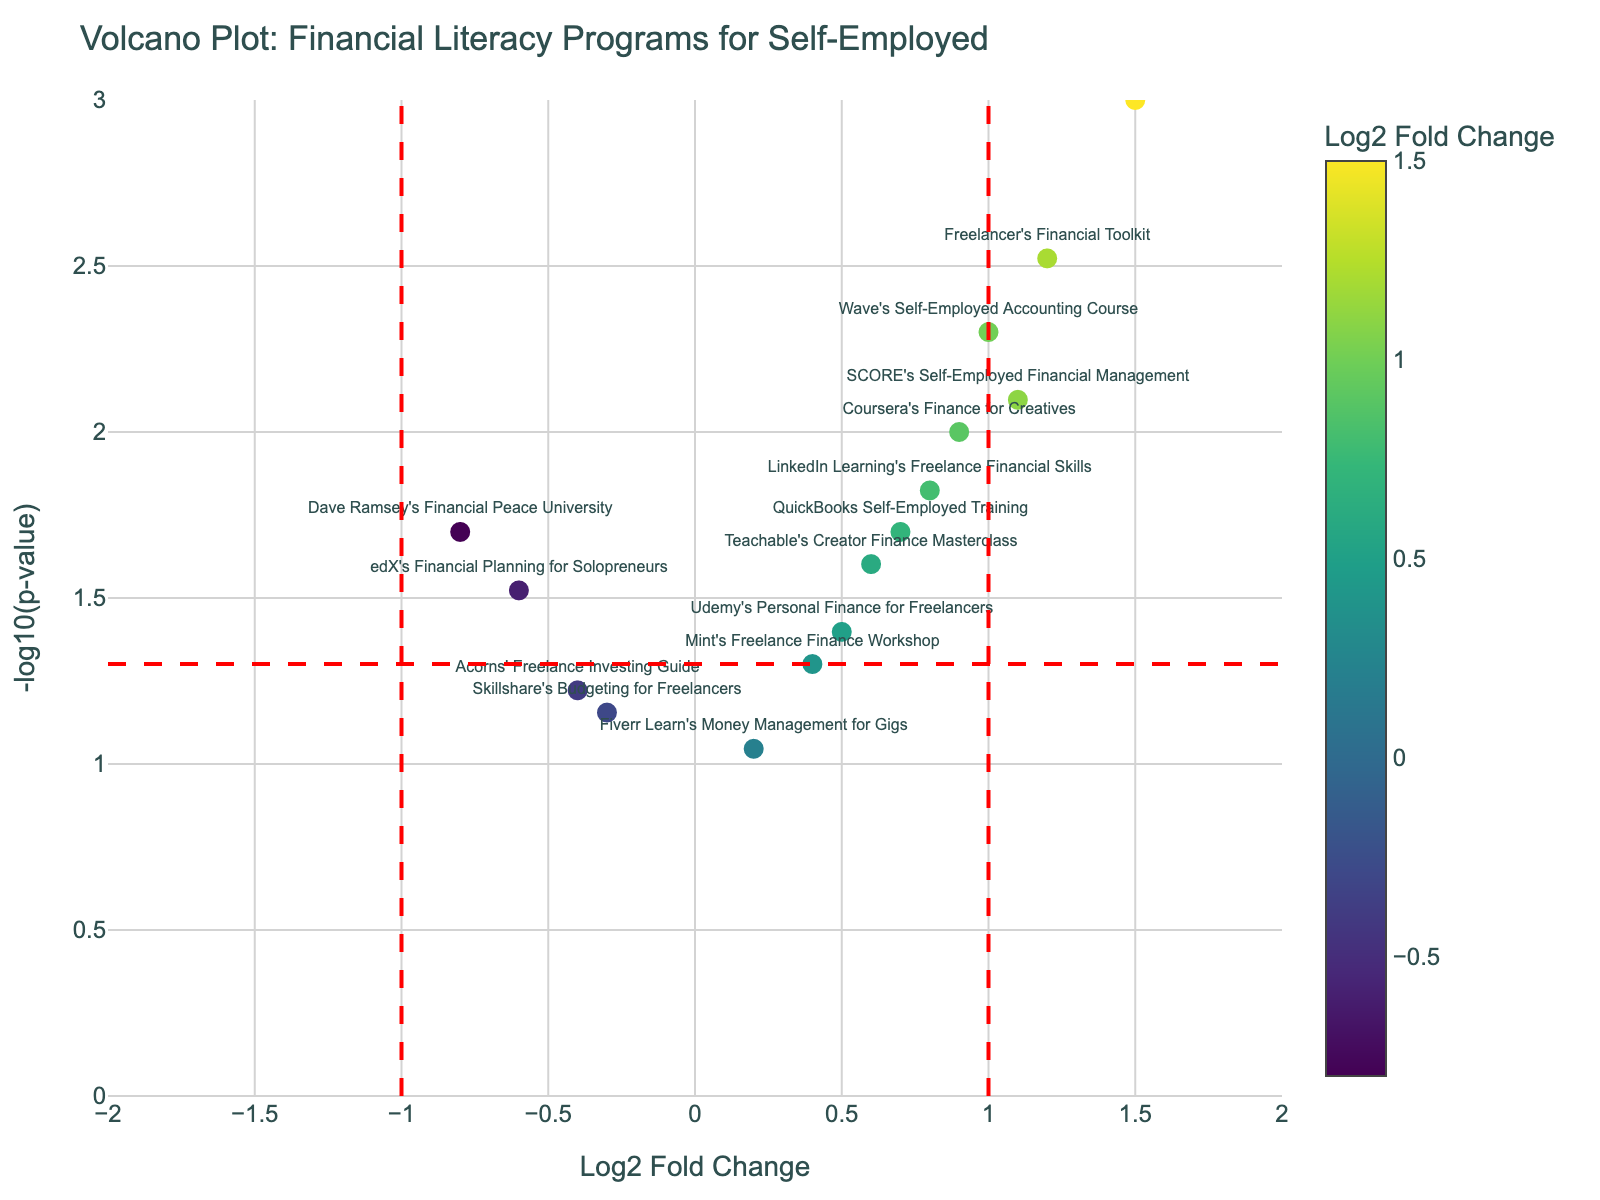What is the title of the plot? The title is displayed at the top of the plot in large, bold letters. It summarizes the plot's subject matter.
Answer: Volcano Plot: Financial Literacy Programs for Self-Employed How many programs are included in the plot? Each program is represented by a data point. Count the number of points.
Answer: There are 15 programs Which program has the highest Log2 Fold Change? Look for the data point with the highest value on the x-axis and identify the associated program.
Answer: FreshBooks' Financial Literacy Course Which program has the smallest p-value? Find the data point with the highest value on the y-axis because a smaller p-value corresponds to a higher -log10(p-value).
Answer: FreshBooks' Financial Literacy Course Which programs have a positive Log2 Fold Change and a p-value less than 0.05? Identify data points with positive x-axis values and a y-axis value higher than approximately 1.30 (-log10(0.05)).
Answer: Freelancer's Financial Toolkit, Coursera's Finance for Creatives, QuickBooks Self-Employed Training, SCORE's Self-Employed Financial Management, edX's Financial Planning for Solopreneurs What is the Log2 Fold Change of 'LinkedIn Learning's Freelance Financial Skills'? Locate the data point labeled 'LinkedIn Learning's Freelance Financial Skills' and note its position on the x-axis.
Answer: 0.8 Which programs have a negative Log2 Fold Change? Look for data points with negative values on the x-axis and list the corresponding programs.
Answer: Dave Ramsey's Financial Peace University, Skillshare's Budgeting for Freelancers, edX's Financial Planning for Solopreneurs, Acorns' Freelance Investing Guide Compare 'Freelancer's Financial Toolkit' and 'Skillshare's Budgeting for Freelancers' in terms of Log2 Fold Change and p-value. 'Freelancer's Financial Toolkit' has a higher Log2 Fold Change (1.2) and lower p-value (0.003) compared to 'Skillshare's Budgeting for Freelancers' which has a Log2 Fold Change of -0.3 and a p-value of 0.07.
Answer: Freelancer's Financial Toolkit has higher values in both metrics How many programs have a Log2 Fold Change greater than 1? Count the number of data points with a Log2 Fold Change value greater than 1.
Answer: There are 4 programs Which programs have a Log2 Fold Change between -0.5 and 0.5 and a p-value less than 0.05? Identify data points that lie within the specified range on the x-axis and above the horizontal threshold line on the y-axis.
Answer: Udemy's Personal Finance for Freelancers, QuickBooks Self-Employed Training 